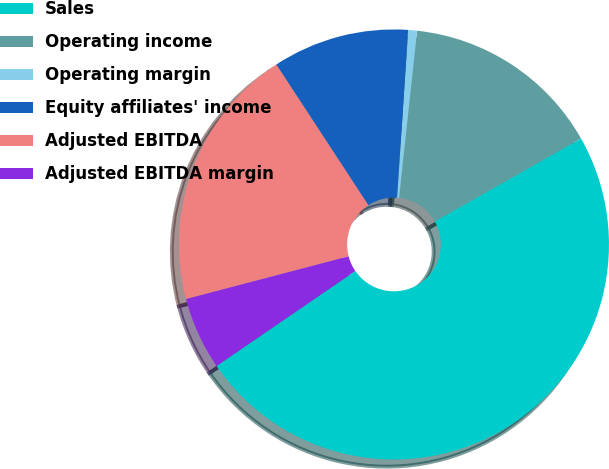Convert chart to OTSL. <chart><loc_0><loc_0><loc_500><loc_500><pie_chart><fcel>Sales<fcel>Operating income<fcel>Operating margin<fcel>Equity affiliates' income<fcel>Adjusted EBITDA<fcel>Adjusted EBITDA margin<nl><fcel>48.66%<fcel>15.07%<fcel>0.67%<fcel>10.27%<fcel>19.87%<fcel>5.47%<nl></chart> 